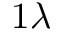Convert formula to latex. <formula><loc_0><loc_0><loc_500><loc_500>1 \lambda</formula> 